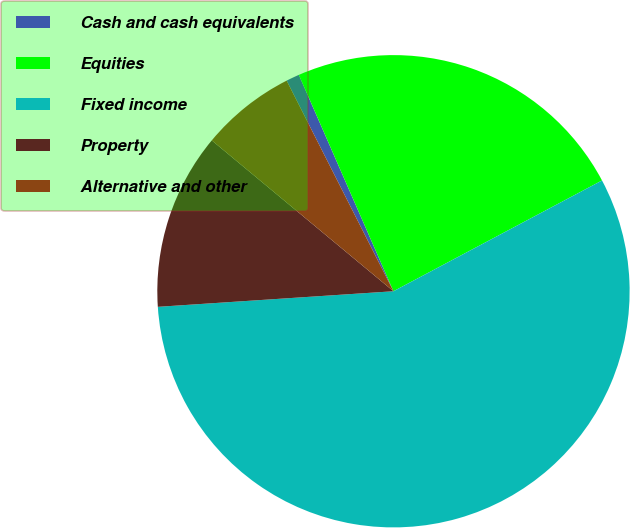Convert chart. <chart><loc_0><loc_0><loc_500><loc_500><pie_chart><fcel>Cash and cash equivalents<fcel>Equities<fcel>Fixed income<fcel>Property<fcel>Alternative and other<nl><fcel>0.91%<fcel>23.79%<fcel>56.72%<fcel>12.08%<fcel>6.5%<nl></chart> 